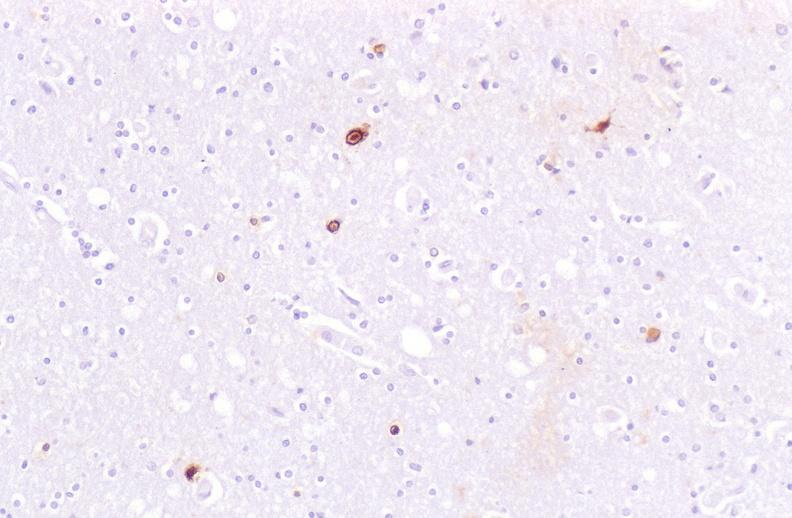s nervous present?
Answer the question using a single word or phrase. Yes 